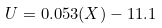<formula> <loc_0><loc_0><loc_500><loc_500>U = 0 . 0 5 3 ( X ) - 1 1 . 1</formula> 